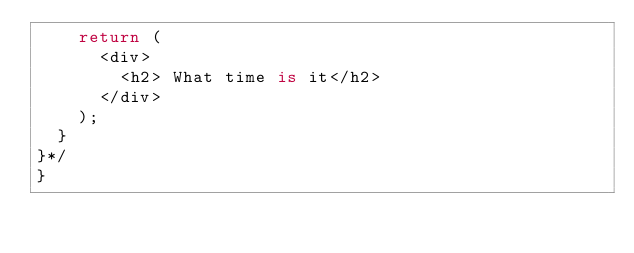<code> <loc_0><loc_0><loc_500><loc_500><_TypeScript_>    return (
      <div>
        <h2> What time is it</h2>
      </div>
    );
  }
}*/
}
</code> 